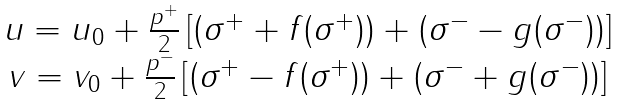<formula> <loc_0><loc_0><loc_500><loc_500>\begin{array} { c } u = u _ { 0 } + \frac { p ^ { + } } 2 \left [ ( \sigma ^ { + } + f ( \sigma ^ { + } ) ) + ( \sigma ^ { - } - g ( \sigma ^ { - } ) ) \right ] \\ v = v _ { 0 } + \frac { p ^ { - } } 2 \left [ ( \sigma ^ { + } - f ( \sigma ^ { + } ) ) + ( \sigma ^ { - } + g ( \sigma ^ { - } ) ) \right ] \end{array}</formula> 